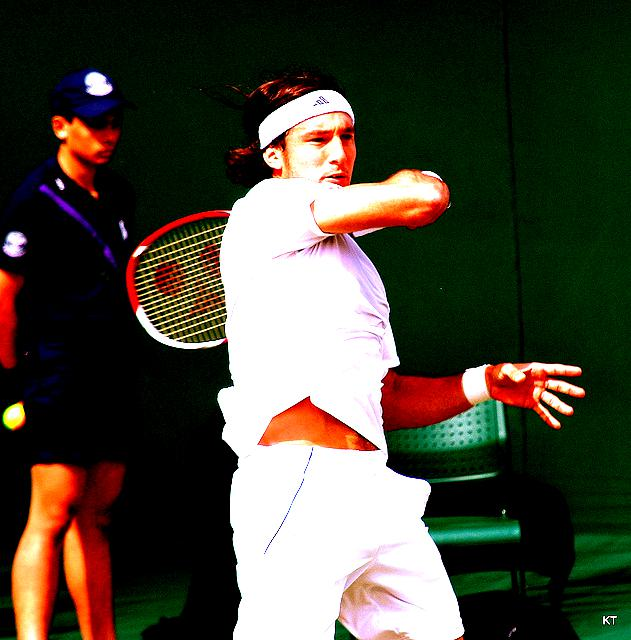Is the lighting sufficient?
A. No
B. Yes
Answer with the option's letter from the given choices directly.
 B. 